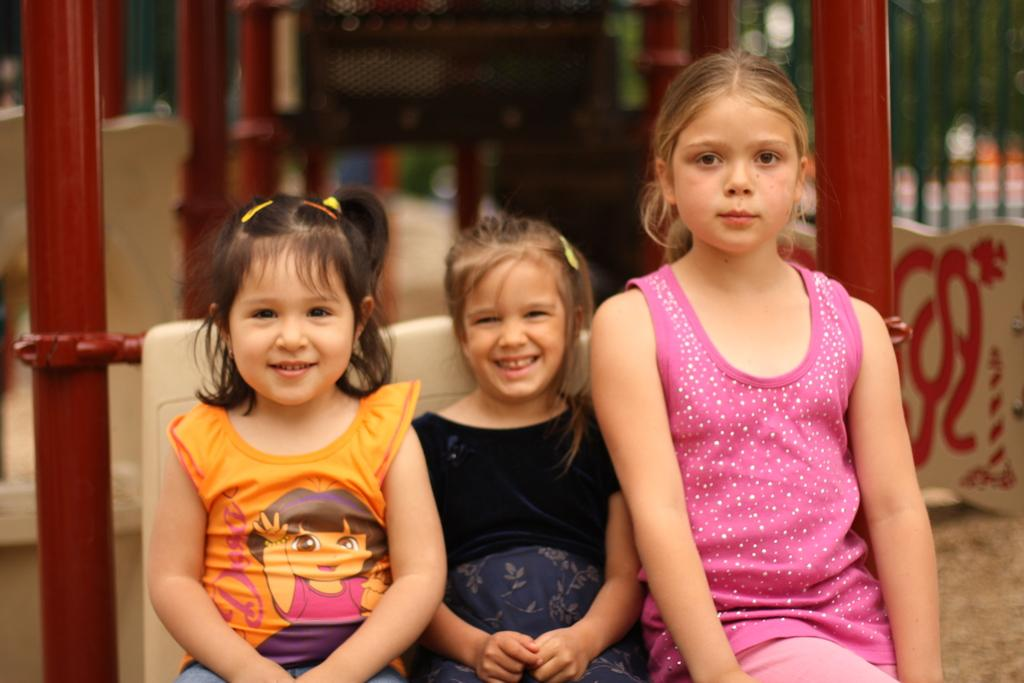Who are the subjects in the image? There are small girls in the image. Where are the girls positioned in the image? The girls are sitting in the center of the image. What can be observed about the background of the image? The background of the image is blurred. How many kittens are playing on the coast in the image? There are no kittens or coast present in the image; it features small girls sitting in the center. What type of engine can be seen powering the girls' activities in the image? There is no engine present in the image; the girls are simply sitting. 